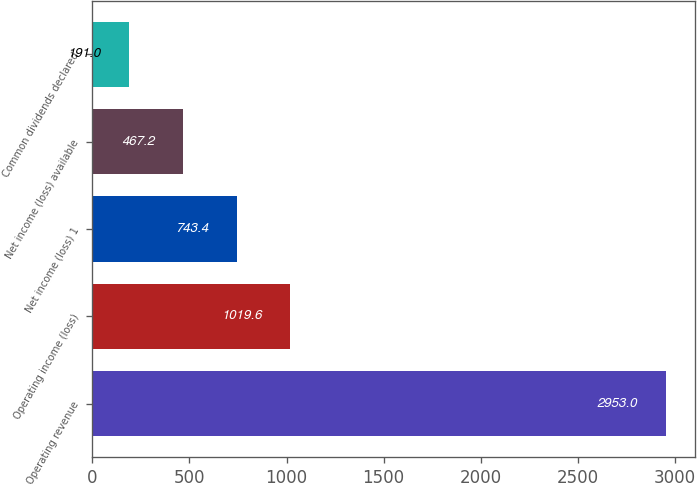Convert chart. <chart><loc_0><loc_0><loc_500><loc_500><bar_chart><fcel>Operating revenue<fcel>Operating income (loss)<fcel>Net income (loss) 1<fcel>Net income (loss) available<fcel>Common dividends declared<nl><fcel>2953<fcel>1019.6<fcel>743.4<fcel>467.2<fcel>191<nl></chart> 